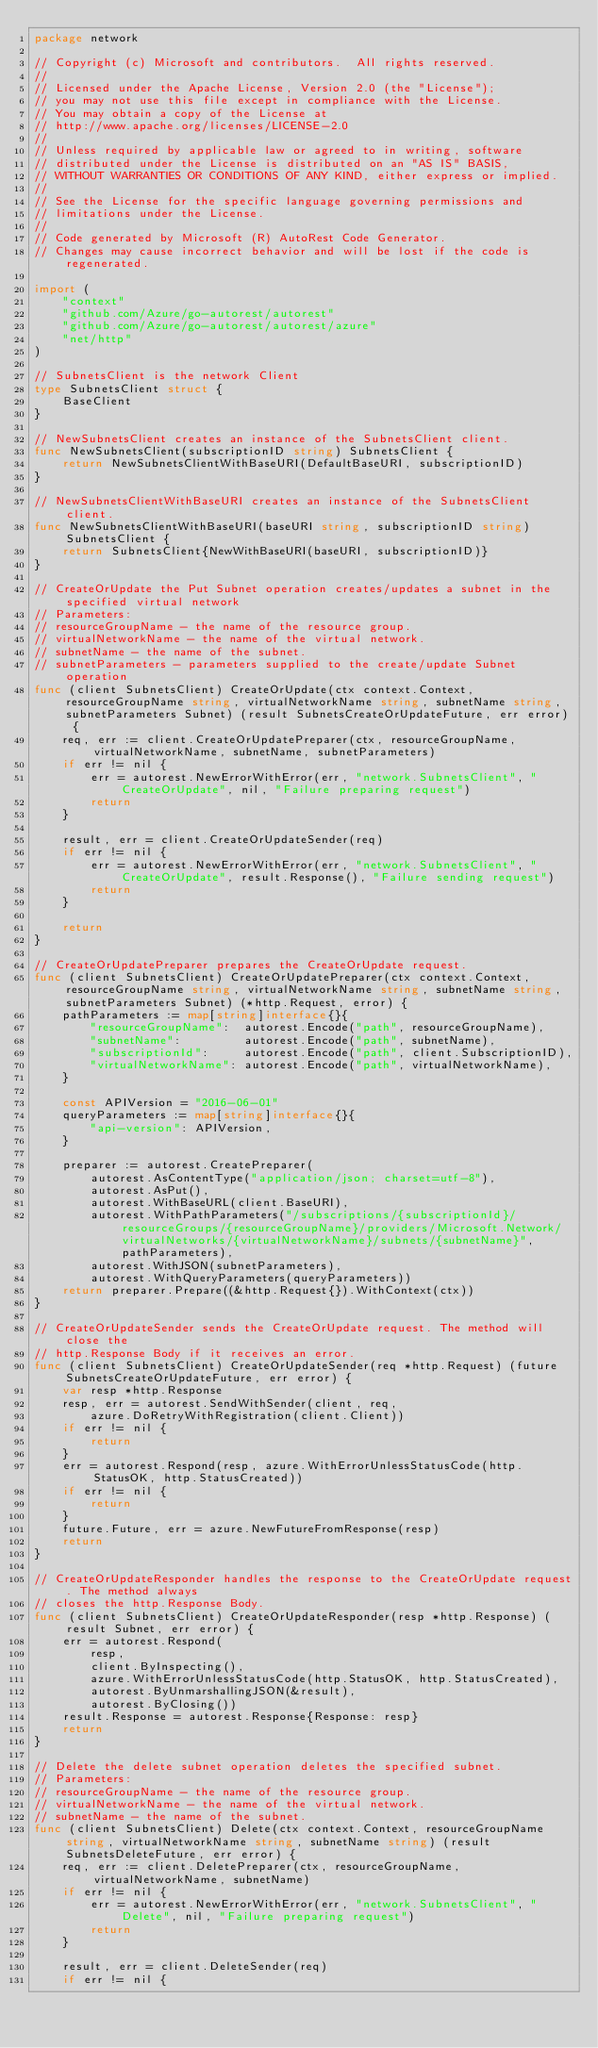Convert code to text. <code><loc_0><loc_0><loc_500><loc_500><_Go_>package network

// Copyright (c) Microsoft and contributors.  All rights reserved.
//
// Licensed under the Apache License, Version 2.0 (the "License");
// you may not use this file except in compliance with the License.
// You may obtain a copy of the License at
// http://www.apache.org/licenses/LICENSE-2.0
//
// Unless required by applicable law or agreed to in writing, software
// distributed under the License is distributed on an "AS IS" BASIS,
// WITHOUT WARRANTIES OR CONDITIONS OF ANY KIND, either express or implied.
//
// See the License for the specific language governing permissions and
// limitations under the License.
//
// Code generated by Microsoft (R) AutoRest Code Generator.
// Changes may cause incorrect behavior and will be lost if the code is regenerated.

import (
	"context"
	"github.com/Azure/go-autorest/autorest"
	"github.com/Azure/go-autorest/autorest/azure"
	"net/http"
)

// SubnetsClient is the network Client
type SubnetsClient struct {
	BaseClient
}

// NewSubnetsClient creates an instance of the SubnetsClient client.
func NewSubnetsClient(subscriptionID string) SubnetsClient {
	return NewSubnetsClientWithBaseURI(DefaultBaseURI, subscriptionID)
}

// NewSubnetsClientWithBaseURI creates an instance of the SubnetsClient client.
func NewSubnetsClientWithBaseURI(baseURI string, subscriptionID string) SubnetsClient {
	return SubnetsClient{NewWithBaseURI(baseURI, subscriptionID)}
}

// CreateOrUpdate the Put Subnet operation creates/updates a subnet in the specified virtual network
// Parameters:
// resourceGroupName - the name of the resource group.
// virtualNetworkName - the name of the virtual network.
// subnetName - the name of the subnet.
// subnetParameters - parameters supplied to the create/update Subnet operation
func (client SubnetsClient) CreateOrUpdate(ctx context.Context, resourceGroupName string, virtualNetworkName string, subnetName string, subnetParameters Subnet) (result SubnetsCreateOrUpdateFuture, err error) {
	req, err := client.CreateOrUpdatePreparer(ctx, resourceGroupName, virtualNetworkName, subnetName, subnetParameters)
	if err != nil {
		err = autorest.NewErrorWithError(err, "network.SubnetsClient", "CreateOrUpdate", nil, "Failure preparing request")
		return
	}

	result, err = client.CreateOrUpdateSender(req)
	if err != nil {
		err = autorest.NewErrorWithError(err, "network.SubnetsClient", "CreateOrUpdate", result.Response(), "Failure sending request")
		return
	}

	return
}

// CreateOrUpdatePreparer prepares the CreateOrUpdate request.
func (client SubnetsClient) CreateOrUpdatePreparer(ctx context.Context, resourceGroupName string, virtualNetworkName string, subnetName string, subnetParameters Subnet) (*http.Request, error) {
	pathParameters := map[string]interface{}{
		"resourceGroupName":  autorest.Encode("path", resourceGroupName),
		"subnetName":         autorest.Encode("path", subnetName),
		"subscriptionId":     autorest.Encode("path", client.SubscriptionID),
		"virtualNetworkName": autorest.Encode("path", virtualNetworkName),
	}

	const APIVersion = "2016-06-01"
	queryParameters := map[string]interface{}{
		"api-version": APIVersion,
	}

	preparer := autorest.CreatePreparer(
		autorest.AsContentType("application/json; charset=utf-8"),
		autorest.AsPut(),
		autorest.WithBaseURL(client.BaseURI),
		autorest.WithPathParameters("/subscriptions/{subscriptionId}/resourceGroups/{resourceGroupName}/providers/Microsoft.Network/virtualNetworks/{virtualNetworkName}/subnets/{subnetName}", pathParameters),
		autorest.WithJSON(subnetParameters),
		autorest.WithQueryParameters(queryParameters))
	return preparer.Prepare((&http.Request{}).WithContext(ctx))
}

// CreateOrUpdateSender sends the CreateOrUpdate request. The method will close the
// http.Response Body if it receives an error.
func (client SubnetsClient) CreateOrUpdateSender(req *http.Request) (future SubnetsCreateOrUpdateFuture, err error) {
	var resp *http.Response
	resp, err = autorest.SendWithSender(client, req,
		azure.DoRetryWithRegistration(client.Client))
	if err != nil {
		return
	}
	err = autorest.Respond(resp, azure.WithErrorUnlessStatusCode(http.StatusOK, http.StatusCreated))
	if err != nil {
		return
	}
	future.Future, err = azure.NewFutureFromResponse(resp)
	return
}

// CreateOrUpdateResponder handles the response to the CreateOrUpdate request. The method always
// closes the http.Response Body.
func (client SubnetsClient) CreateOrUpdateResponder(resp *http.Response) (result Subnet, err error) {
	err = autorest.Respond(
		resp,
		client.ByInspecting(),
		azure.WithErrorUnlessStatusCode(http.StatusOK, http.StatusCreated),
		autorest.ByUnmarshallingJSON(&result),
		autorest.ByClosing())
	result.Response = autorest.Response{Response: resp}
	return
}

// Delete the delete subnet operation deletes the specified subnet.
// Parameters:
// resourceGroupName - the name of the resource group.
// virtualNetworkName - the name of the virtual network.
// subnetName - the name of the subnet.
func (client SubnetsClient) Delete(ctx context.Context, resourceGroupName string, virtualNetworkName string, subnetName string) (result SubnetsDeleteFuture, err error) {
	req, err := client.DeletePreparer(ctx, resourceGroupName, virtualNetworkName, subnetName)
	if err != nil {
		err = autorest.NewErrorWithError(err, "network.SubnetsClient", "Delete", nil, "Failure preparing request")
		return
	}

	result, err = client.DeleteSender(req)
	if err != nil {</code> 